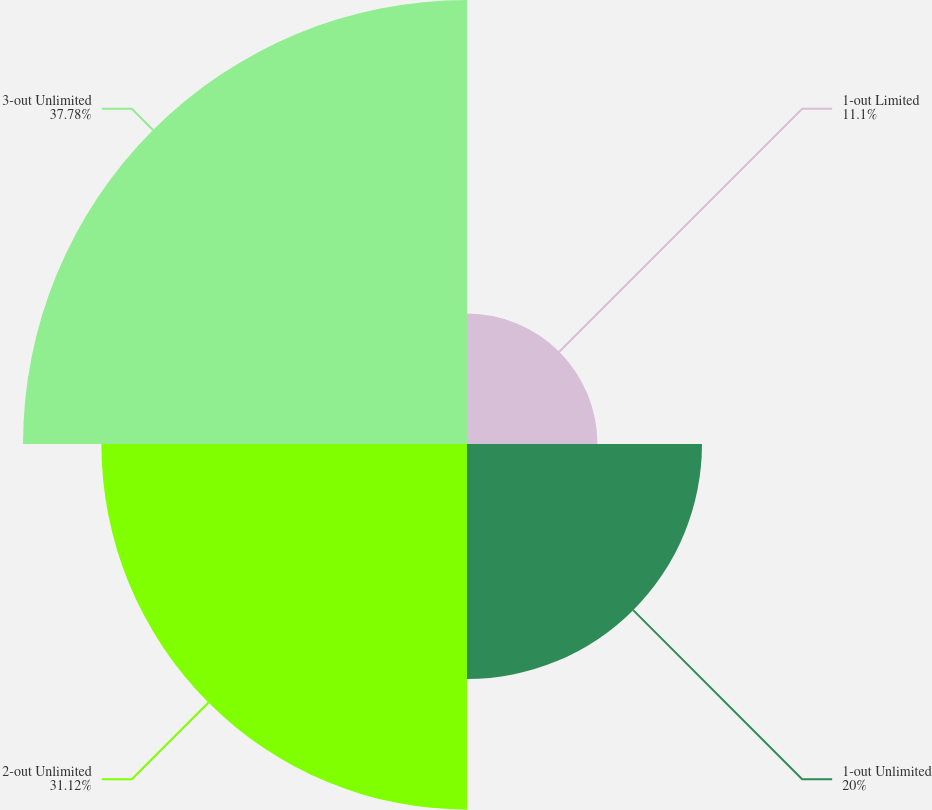Convert chart. <chart><loc_0><loc_0><loc_500><loc_500><pie_chart><fcel>1-out Limited<fcel>1-out Unlimited<fcel>2-out Unlimited<fcel>3-out Unlimited<nl><fcel>11.1%<fcel>20.0%<fcel>31.12%<fcel>37.79%<nl></chart> 